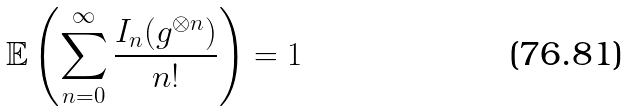<formula> <loc_0><loc_0><loc_500><loc_500>\mathbb { E } \left ( \sum _ { n = 0 } ^ { \infty } \frac { I _ { n } ( g ^ { \otimes n } ) } { n ! } \right ) = 1</formula> 